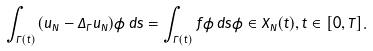Convert formula to latex. <formula><loc_0><loc_0><loc_500><loc_500>\int _ { \Gamma ( t ) } ( \dot { u } _ { N } - \Delta _ { \Gamma } u _ { N } ) \phi \, d s = \int _ { \Gamma ( t ) } f \phi \, d s \phi \in X _ { N } ( t ) , t \in [ 0 , T ] .</formula> 